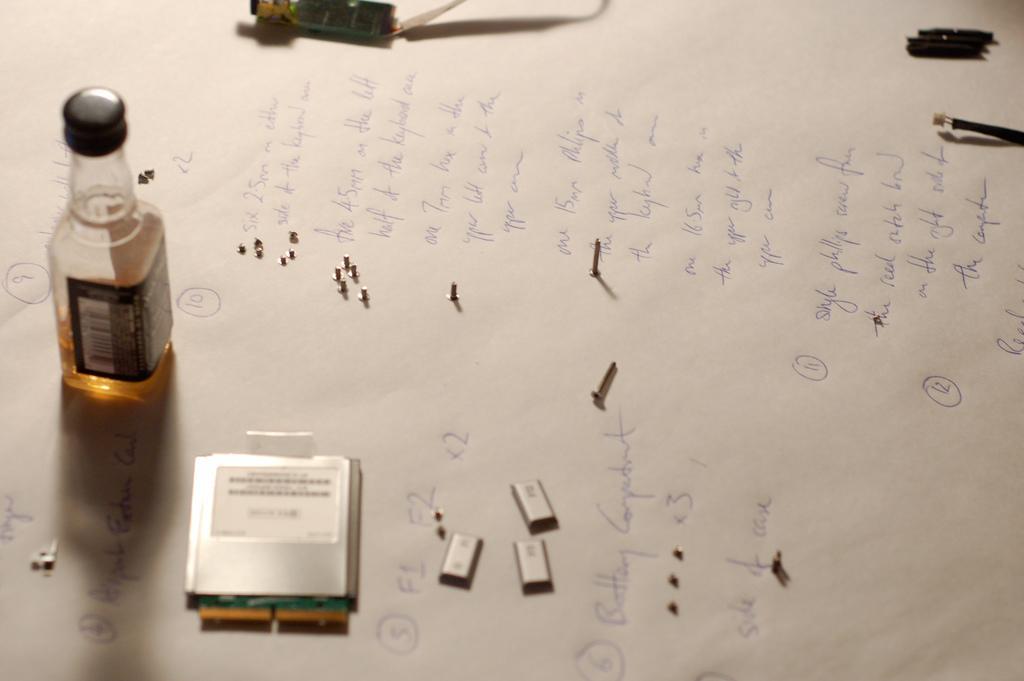Can you describe this image briefly? there is a paper on the paper there is a bottle 